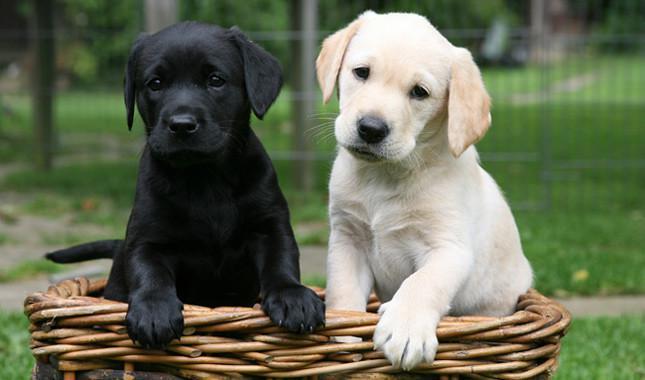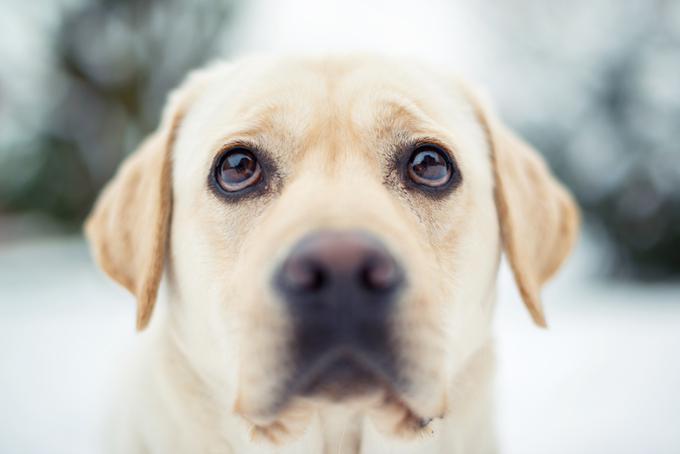The first image is the image on the left, the second image is the image on the right. For the images shown, is this caption "In one image a group of dogs is four different colors, while in the other image, two dogs have the same coloring." true? Answer yes or no. No. The first image is the image on the left, the second image is the image on the right. Given the left and right images, does the statement "The left image contains more dogs than the right image." hold true? Answer yes or no. Yes. 